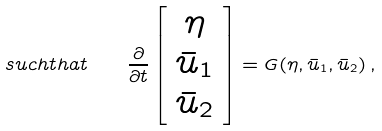<formula> <loc_0><loc_0><loc_500><loc_500>s u c h t h a t \quad \frac { \partial } { \partial t } \left [ \begin{array} { c } \eta \\ \bar { u } _ { 1 } \\ \bar { u } _ { 2 } \end{array} \right ] = { G } ( \eta , \bar { u } _ { 1 } , \bar { u } _ { 2 } ) \, ,</formula> 